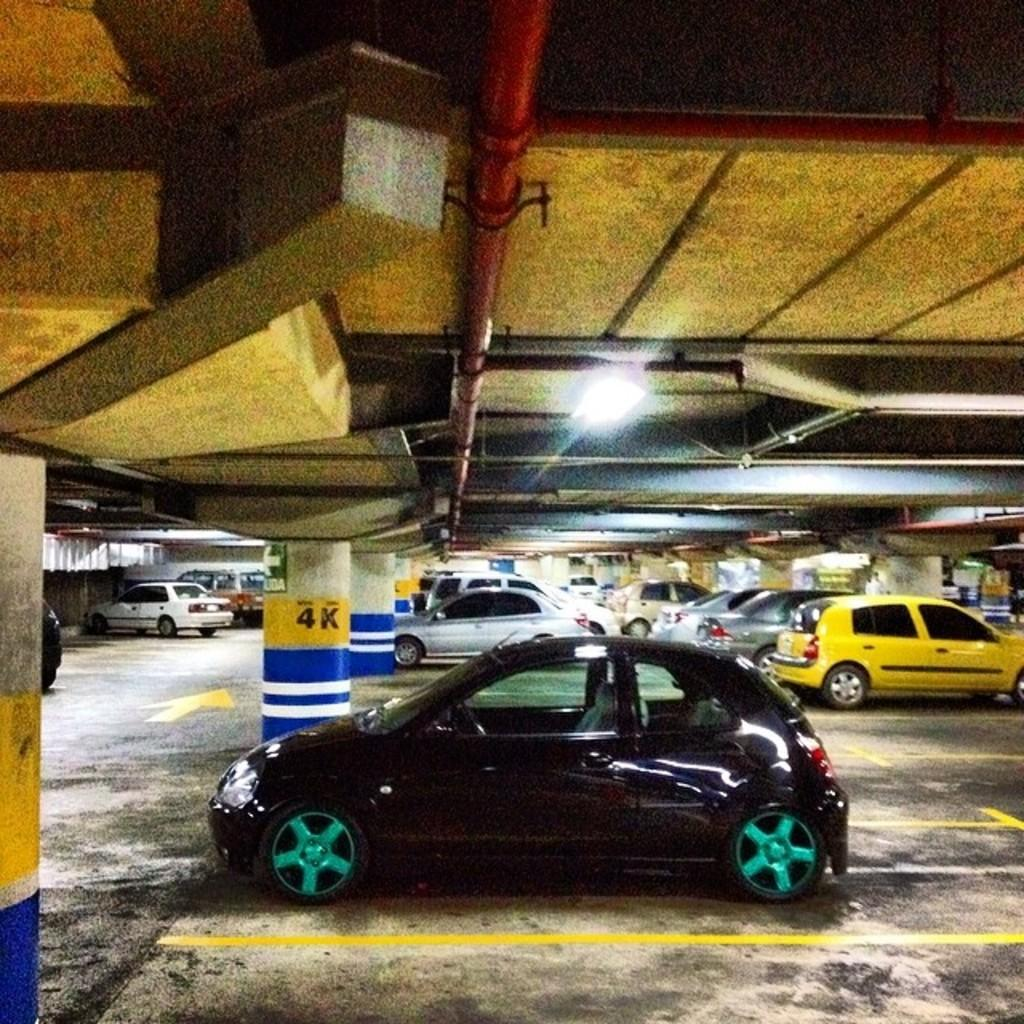<image>
Offer a succinct explanation of the picture presented. a 4k sign that is next to a car 